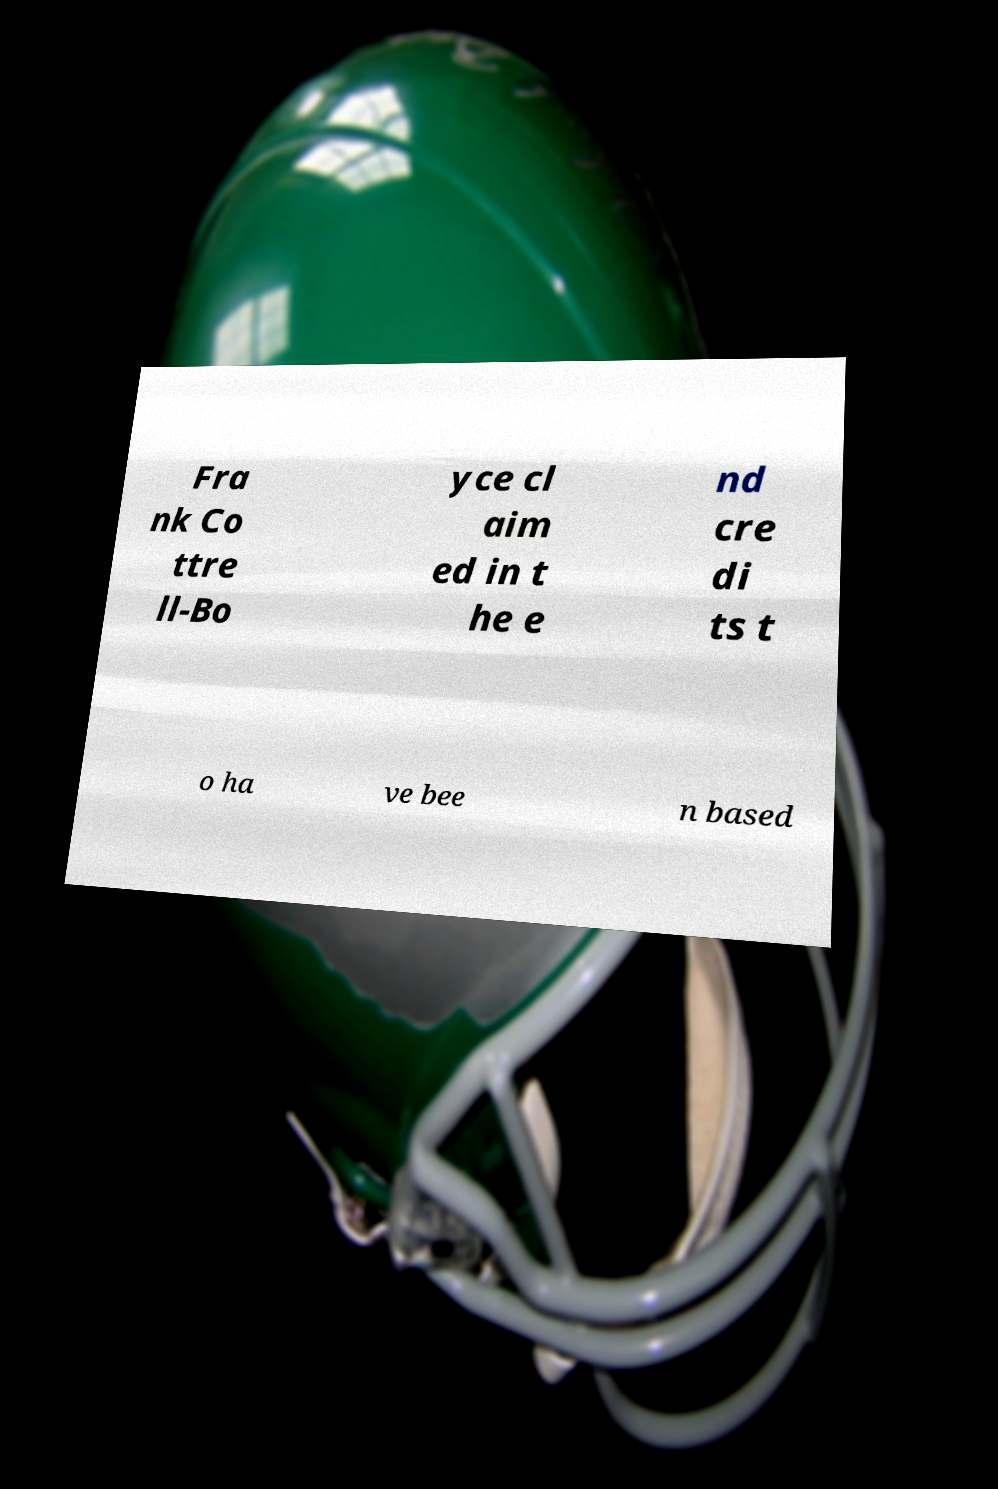Can you accurately transcribe the text from the provided image for me? Fra nk Co ttre ll-Bo yce cl aim ed in t he e nd cre di ts t o ha ve bee n based 